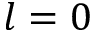Convert formula to latex. <formula><loc_0><loc_0><loc_500><loc_500>l = 0</formula> 